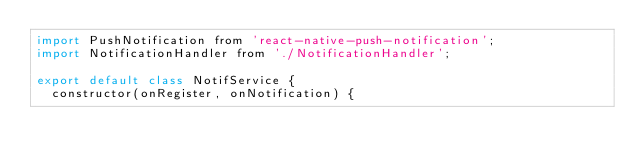Convert code to text. <code><loc_0><loc_0><loc_500><loc_500><_JavaScript_>import PushNotification from 'react-native-push-notification';
import NotificationHandler from './NotificationHandler';

export default class NotifService {
  constructor(onRegister, onNotification) {</code> 